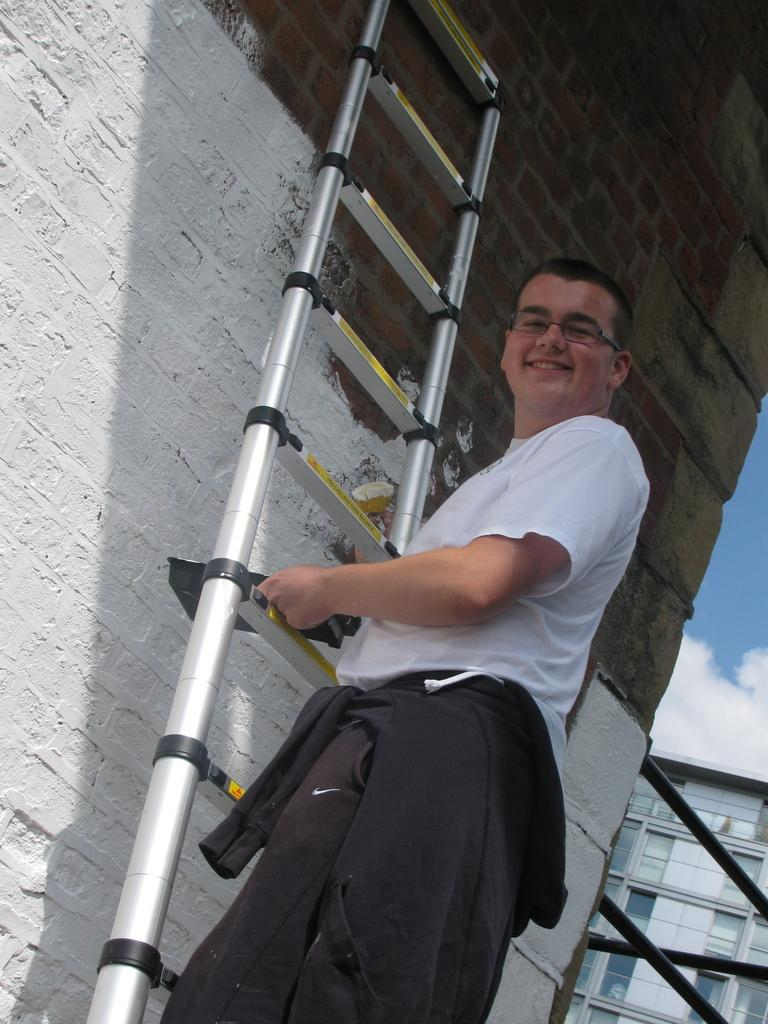What is the person in the image doing? The person is climbing a ladder in the image. Where is the ladder located? The ladder is on a building. Are there any other buildings visible in the image? Yes, there is another building beside the one with the ladder. What type of bushes can be seen growing on the person's hand in the image? There are no bushes visible on the person's hand in the image. Can you describe the wave pattern on the building with the ladder? There is no wave pattern visible on the building with the ladder in the image. 